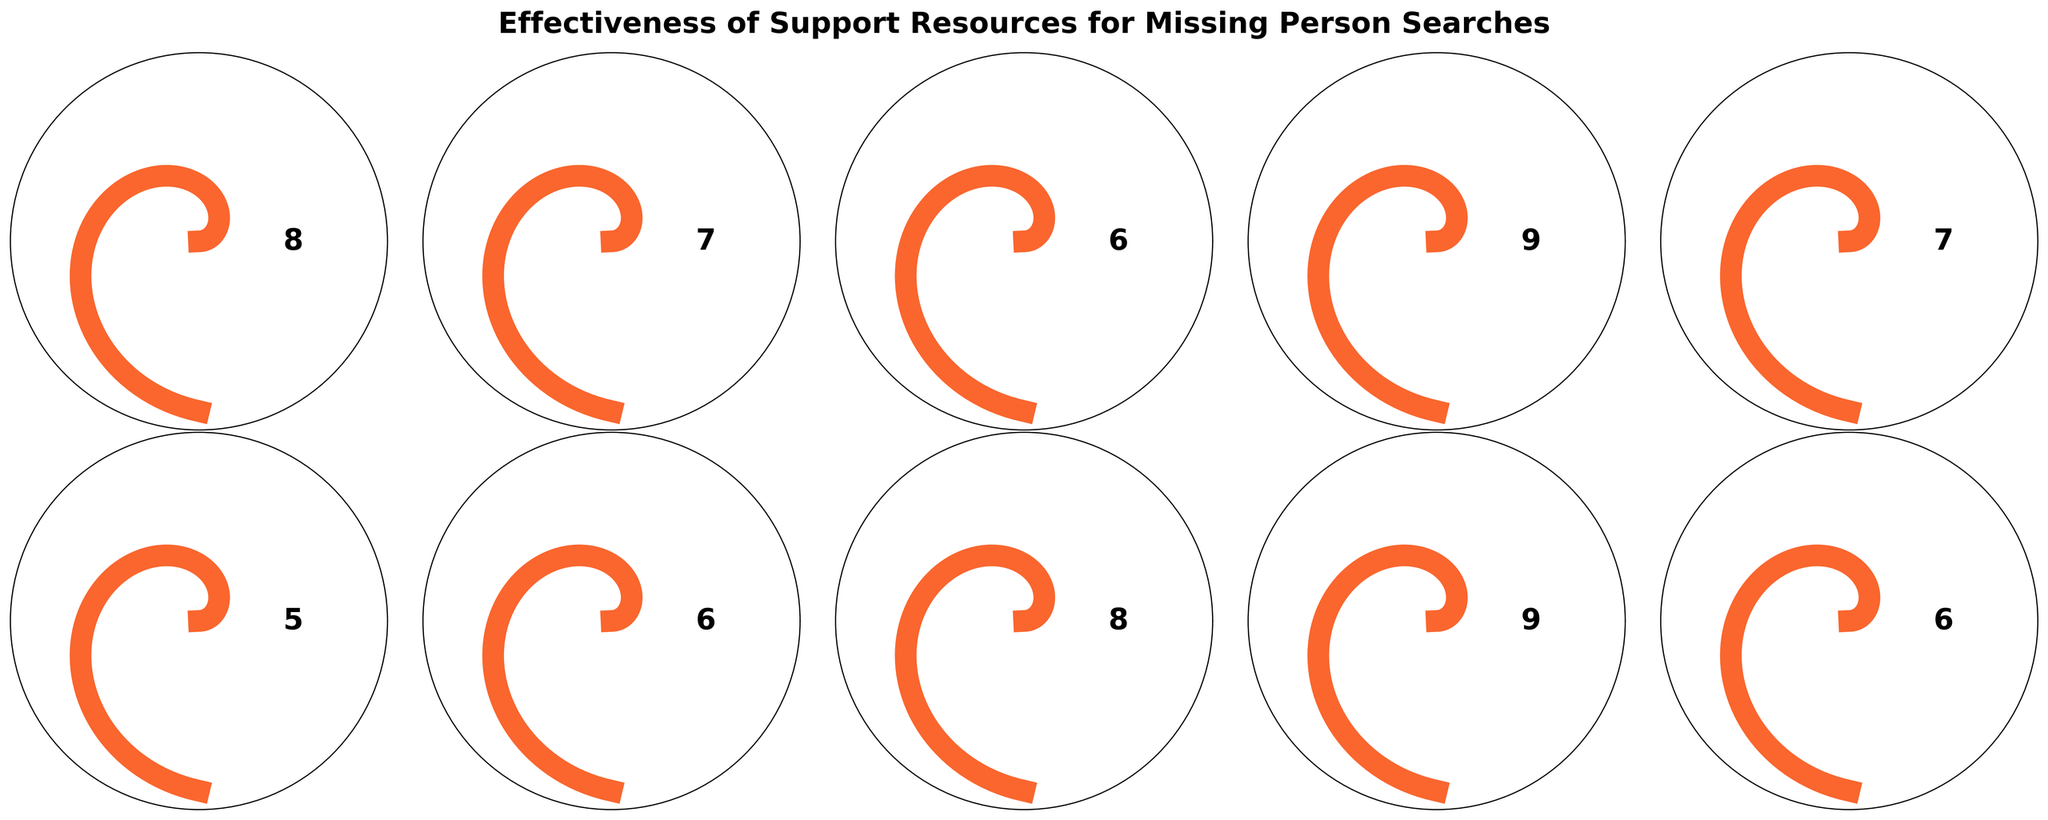What's the title of the figure? The title of the figure is usually placed at the top of the plot or chart. In this case, it is placed at the top of the combined gauge charts.
Answer: Effectiveness of Support Resources for Missing Person Searches Which resource has the highest effectiveness rating? The resource with the highest effectiveness rating will have the needle of the gauge chart pointing the furthest to the right. In this figure, the "Search and Rescue Teams" and "Amber Alert System" both have a rating of 9.
Answer: Search and Rescue Teams and Amber Alert System How many resources are rated 6? We need to identify all the gauge charts where the effectiveness value shown in the center is 6. In this figure, the resources with a rating of 6 are "Social Media Campaigns", "Missing Persons Websites", and "Counseling Services".
Answer: 3 Which resources have an effectiveness rating greater than 7 but less than 9? We need to identify the gauge charts where the effectiveness value is greater than 7 but less than 9. The resources with these values are "Local Law Enforcement" and "Volunteer Search Parties" with a rating of 8, and "National Missing Persons Hotline" and "Support Groups for Families" with a rating of 7.
Answer: Local Law Enforcement, Volunteer Search Parties, National Missing Persons Hotline, Support Groups for Families What is the average effectiveness rating for all resources? To find the average, sum up all the effectiveness ratings and divide by the number of resources. The ratings are (8 + 7 + 6 + 9 + 7 + 5 + 6 + 8 + 9 + 6) which adds up to 71. There are 10 resources, so the average is 71/10 = 7.1.
Answer: 7.1 How do the effectiveness ratings compare between "Social Media Campaigns" and "Private Investigators"? We need to compare the effectiveness rating values shown in the gauge charts for these two resources. "Social Media Campaigns" is rated 6, while "Private Investigators" is rated 5.
Answer: Social Media Campaigns is higher Which resource has the lowest effectiveness rating? The resource with the lowest effectiveness rating will have the needle of the gauge chart pointing the least to the right. In this figure, the "Private Investigators" resource has the lowest rating of 5.
Answer: Private Investigators Are there more resources with an effectiveness rating of 7 or 6? Count the number of gauge charts where the effectiveness value is 7 and those where it is 6. There are 3 resources rated 6 (Social Media Campaigns, Missing Persons Websites, Counseling Services) and 2 resources rated 7 (National Missing Persons Hotline, Support Groups for Families).
Answer: 6 What's the combined total effectiveness rating for "Search and Rescue Teams", "Amber Alert System", and "Local Law Enforcement"? Add the effectiveness ratings of the specified resources: "Search and Rescue Teams" (9) + "Amber Alert System" (9) + "Local Law Enforcement" (8). The total is 9 + 9 + 8 = 26.
Answer: 26 